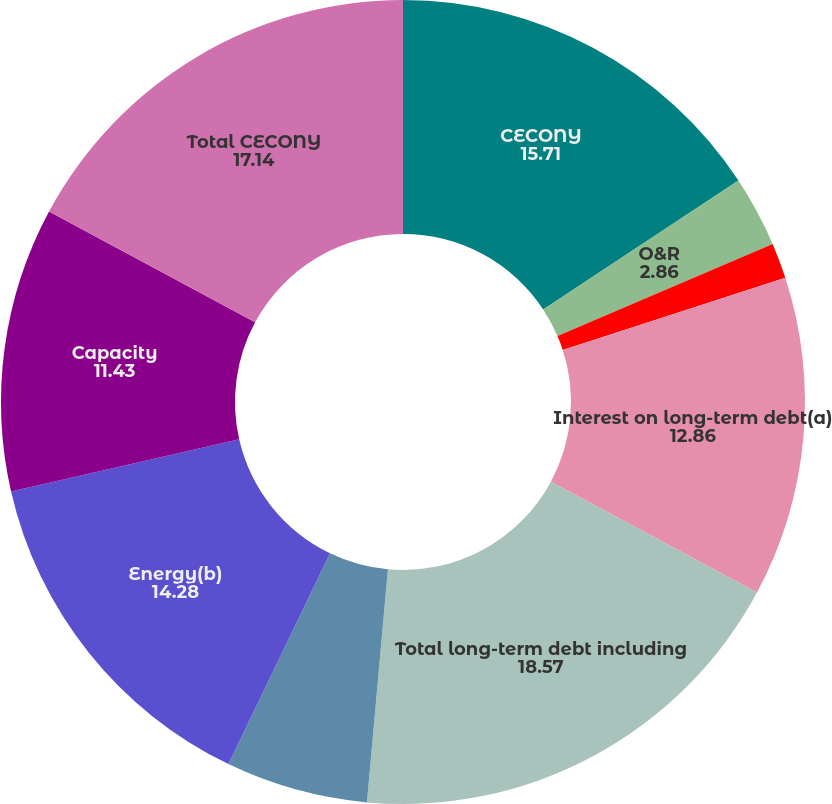<chart> <loc_0><loc_0><loc_500><loc_500><pie_chart><fcel>CECONY<fcel>O&R<fcel>Competitive energy businesses<fcel>Interest on long-term debt(a)<fcel>Total long-term debt including<fcel>Total operating leases<fcel>Energy(b)<fcel>Capacity<fcel>Total CECONY<nl><fcel>15.71%<fcel>2.86%<fcel>1.43%<fcel>12.86%<fcel>18.57%<fcel>5.72%<fcel>14.28%<fcel>11.43%<fcel>17.14%<nl></chart> 